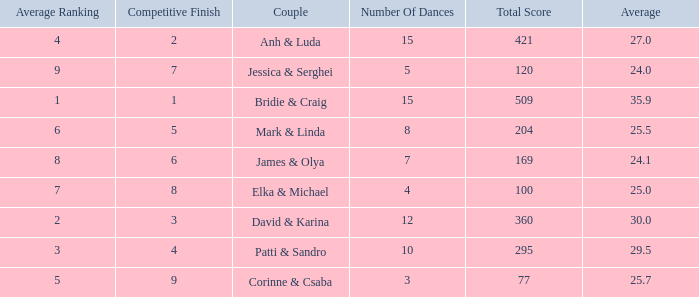What is the total score when 7 is the average ranking? 100.0. 